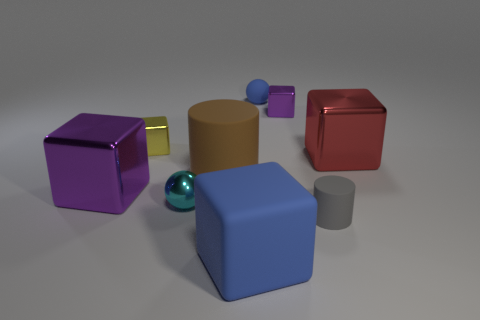Subtract all green blocks. Subtract all gray cylinders. How many blocks are left? 5 Subtract all spheres. How many objects are left? 7 Subtract 0 cyan cylinders. How many objects are left? 9 Subtract all tiny yellow metallic cubes. Subtract all gray rubber cylinders. How many objects are left? 7 Add 5 cyan balls. How many cyan balls are left? 6 Add 1 large red rubber balls. How many large red rubber balls exist? 1 